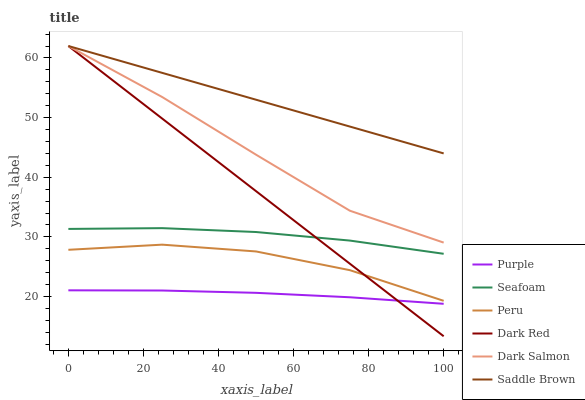Does Purple have the minimum area under the curve?
Answer yes or no. Yes. Does Saddle Brown have the maximum area under the curve?
Answer yes or no. Yes. Does Dark Red have the minimum area under the curve?
Answer yes or no. No. Does Dark Red have the maximum area under the curve?
Answer yes or no. No. Is Dark Red the smoothest?
Answer yes or no. Yes. Is Peru the roughest?
Answer yes or no. Yes. Is Seafoam the smoothest?
Answer yes or no. No. Is Seafoam the roughest?
Answer yes or no. No. Does Dark Red have the lowest value?
Answer yes or no. Yes. Does Seafoam have the lowest value?
Answer yes or no. No. Does Saddle Brown have the highest value?
Answer yes or no. Yes. Does Seafoam have the highest value?
Answer yes or no. No. Is Seafoam less than Dark Salmon?
Answer yes or no. Yes. Is Seafoam greater than Purple?
Answer yes or no. Yes. Does Purple intersect Dark Red?
Answer yes or no. Yes. Is Purple less than Dark Red?
Answer yes or no. No. Is Purple greater than Dark Red?
Answer yes or no. No. Does Seafoam intersect Dark Salmon?
Answer yes or no. No. 